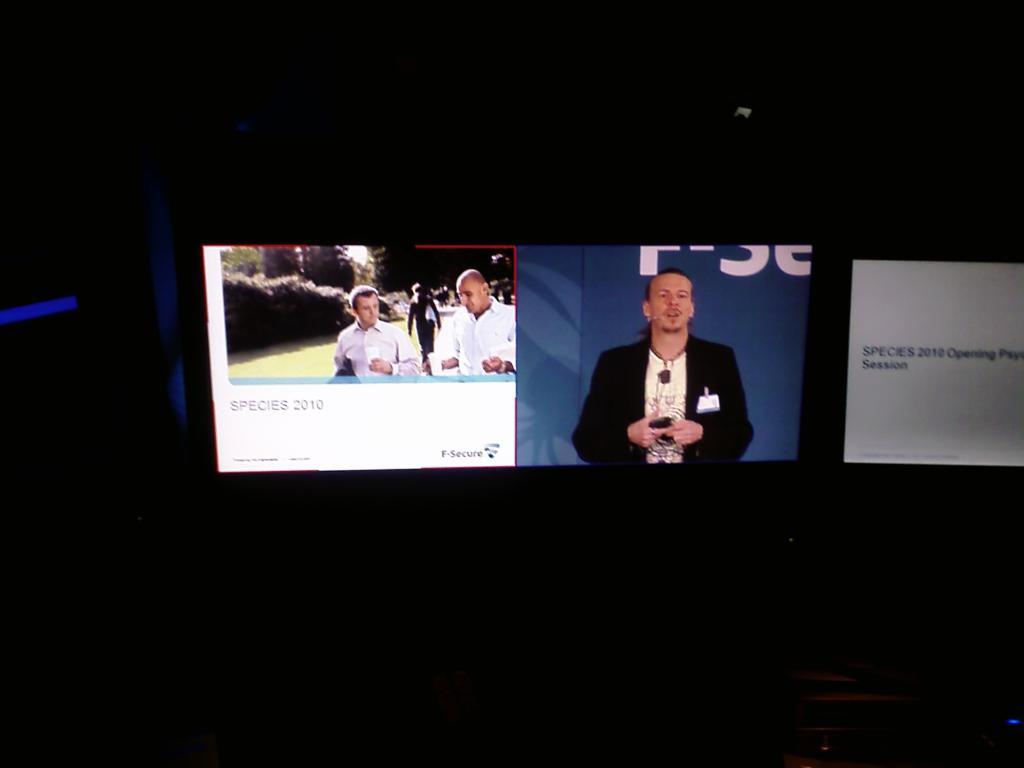<image>
Present a compact description of the photo's key features. In a dark room there are three different screens, two of which are displaying information regarding species in 2010. 